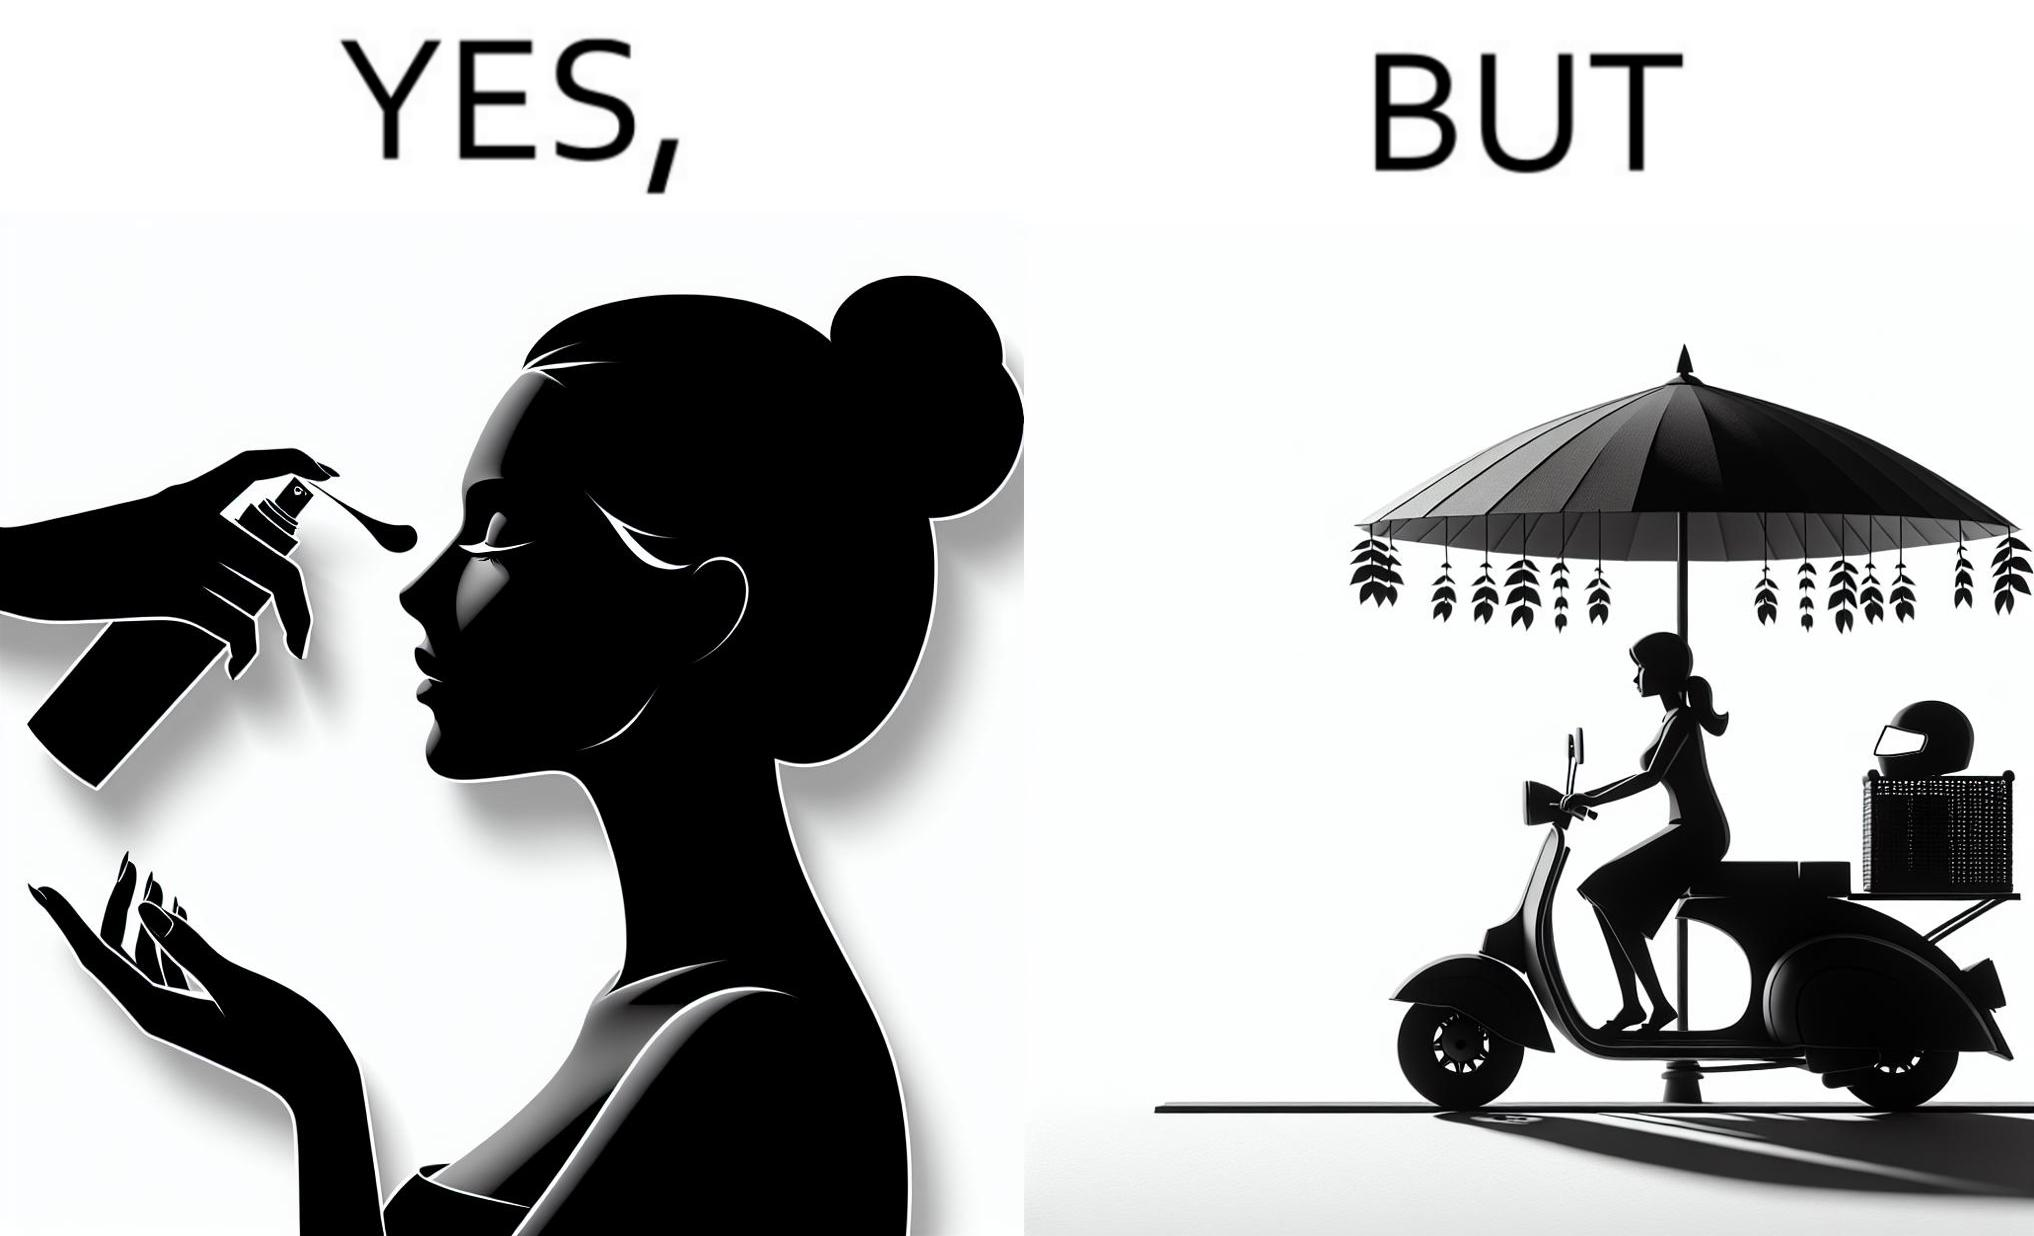What makes this image funny or satirical? The image is funny because while the woman is concerned about protection from the sun rays, she is not concerned about her safety while riding a scooter. 